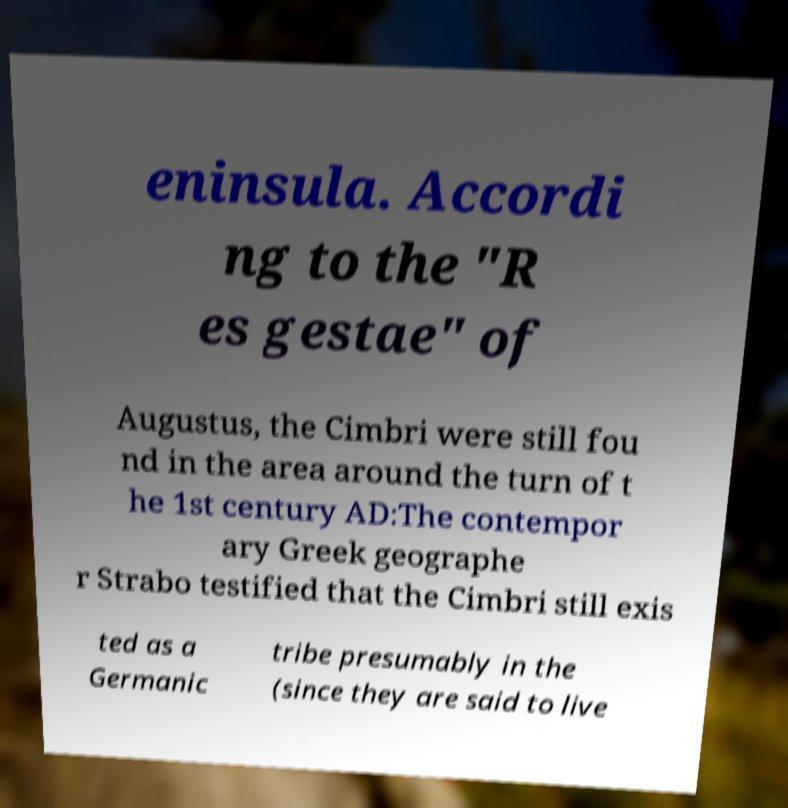Can you read and provide the text displayed in the image?This photo seems to have some interesting text. Can you extract and type it out for me? eninsula. Accordi ng to the "R es gestae" of Augustus, the Cimbri were still fou nd in the area around the turn of t he 1st century AD:The contempor ary Greek geographe r Strabo testified that the Cimbri still exis ted as a Germanic tribe presumably in the (since they are said to live 